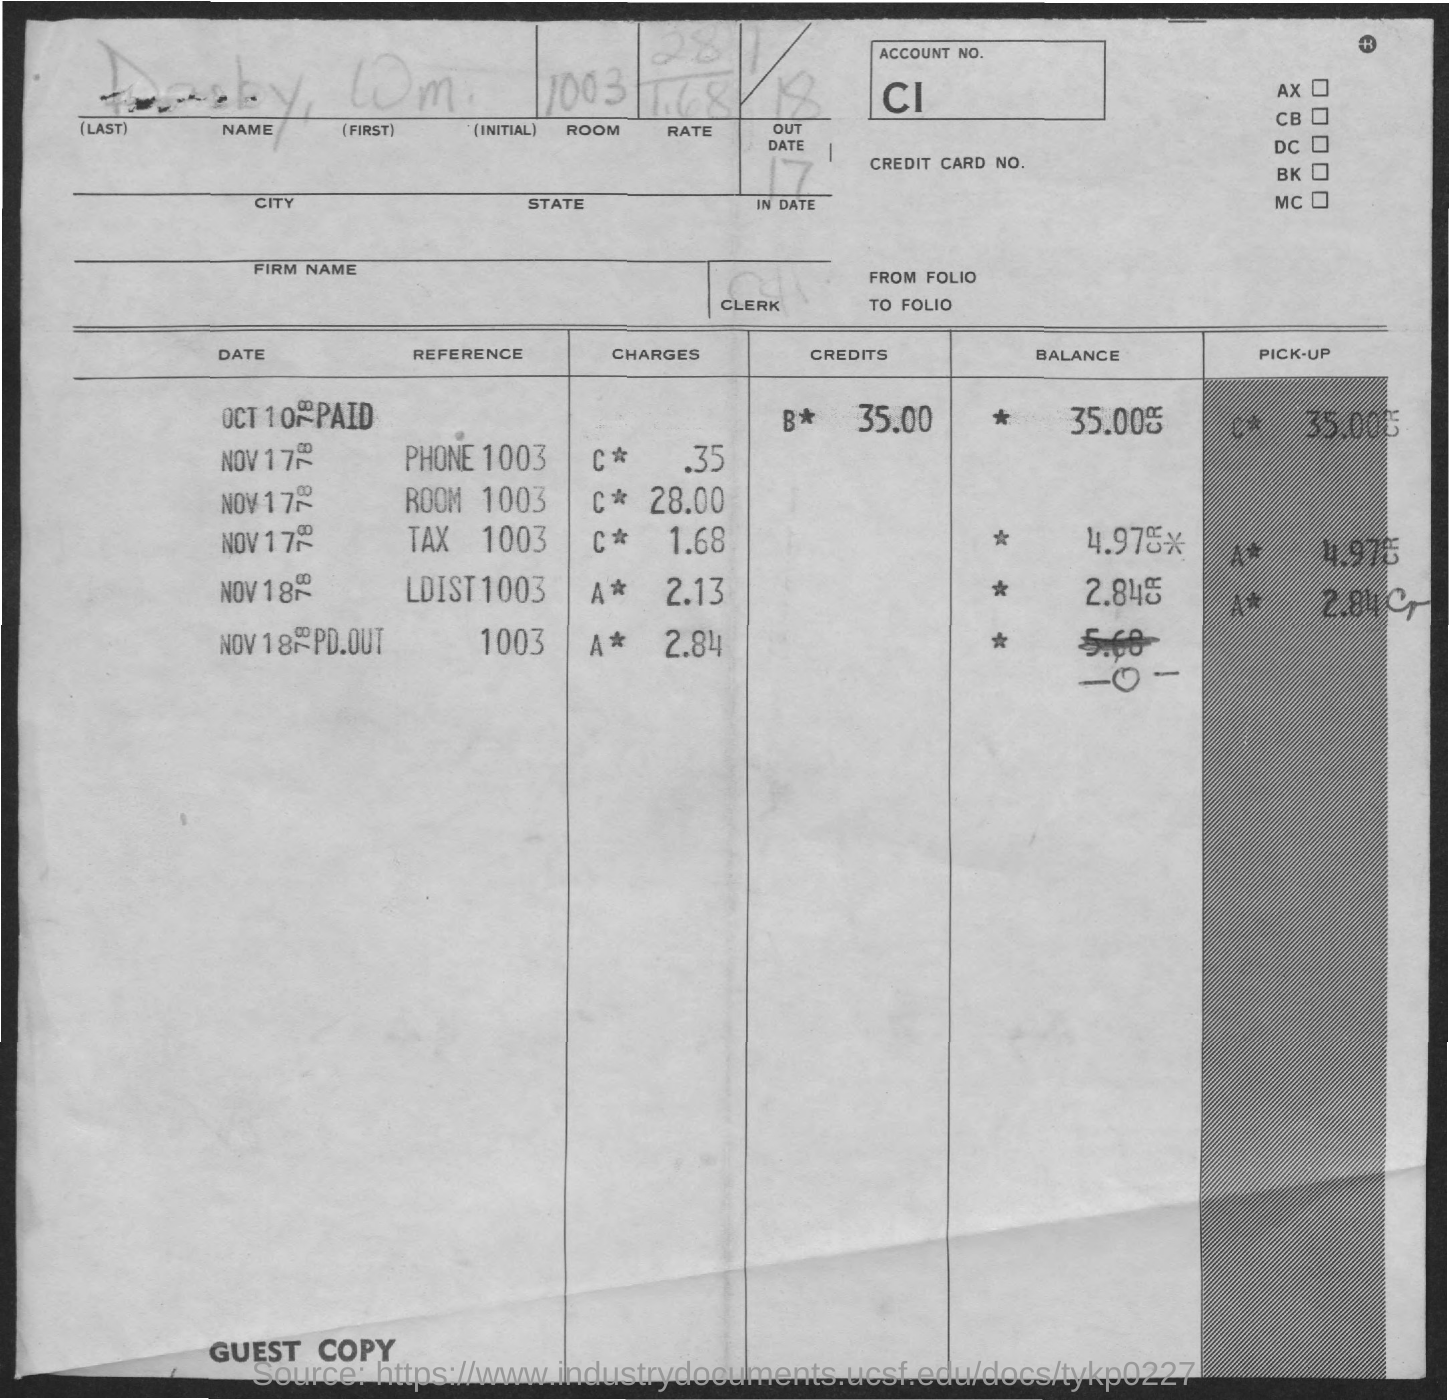What is the account No.?
Your answer should be very brief. CI. What is the Name?
Offer a very short reply. Darby, Wm. What is the room?
Your answer should be very brief. 1003. What is the "In Date"?
Your response must be concise. 17. What are the Phone 1003 charges?
Offer a very short reply. .35. What are the Room 1003 charges?
Your response must be concise. 28.00. What are the Tax 1003 charges?
Offer a terse response. C* 1.68. What are the LDIST 1003 charges?
Offer a very short reply. A* 2.13. 